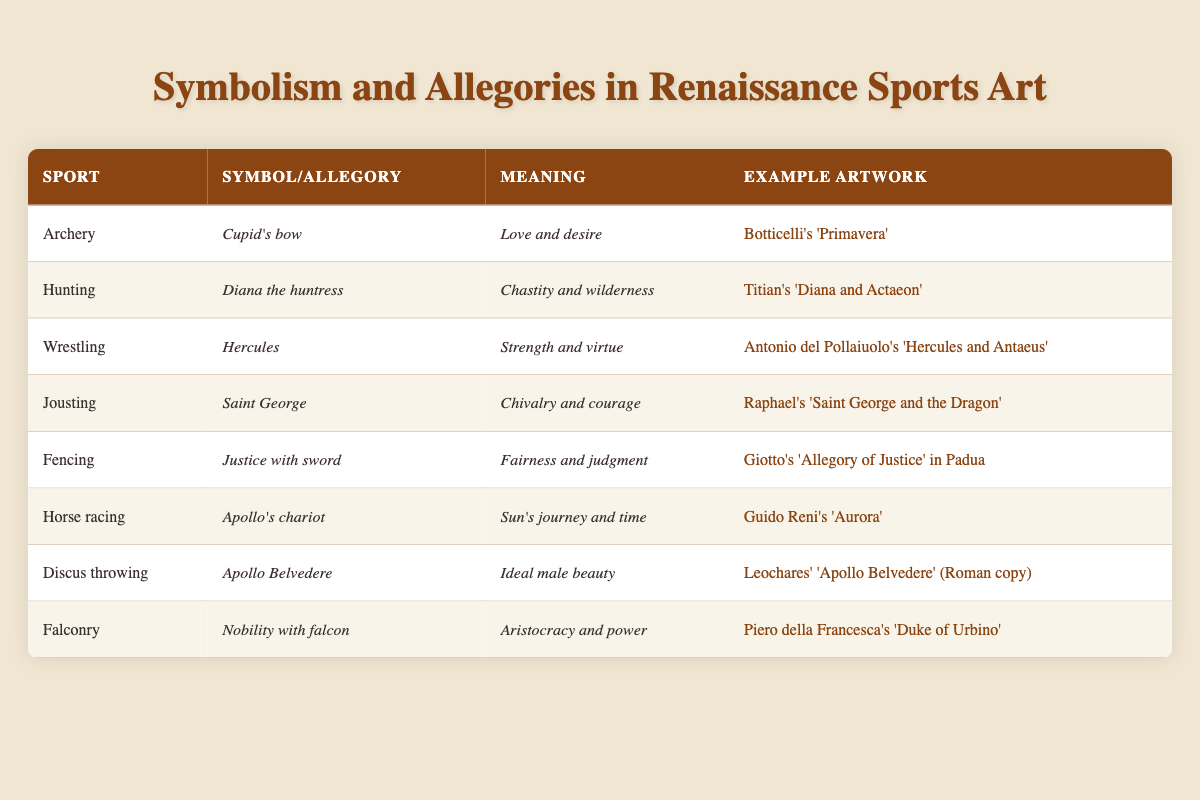What symbol is associated with archery in Renaissance art? The table lists "Cupid's bow" as the symbol associated with archery.
Answer: Cupid's bow Which sport is represented by the symbol of Diana the huntress? According to the table, the sport represented by the symbol of Diana the huntress is "Hunting."
Answer: Hunting Is "Justice with sword" associated with fencing? The table confirms that "Justice with sword" is indeed the symbol associated with fencing.
Answer: Yes What is the meaning of the symbol "Apollo's chariot"? The meaning of "Apollo's chariot," as stated in the table, represents the "Sun's journey and time."
Answer: Sun's journey and time Which sport has the example artwork "Hercules and Antaeus"? The artwork "Hercules and Antaeus" corresponds to the sport of "Wrestling" as indicated in the table.
Answer: Wrestling How many sports have meanings associated with themes of nobility or aristocracy? The table indicates that two sports are associated with themes of nobility or aristocracy: Falconry and Horse racing. Both represent nobility and power, hence the answer is 2.
Answer: 2 Which sport's symbolism conveys concepts of strength and virtue? The table shows that the symbolism related to strength and virtue is linked with the sport of "Wrestling."
Answer: Wrestling What is the average number of example artworks listed for sports associated with love, strength, and chivalry? The relevant sports are Archery, Wrestling, and Jousting; there is one example artwork listed for each, leading to an average of 1 (3 artworks / 3 sports).
Answer: 1 Which sport has the example artwork "Aurora"? The example artwork "Aurora" is connected to the sport of "Horse racing" according to the table.
Answer: Horse racing 